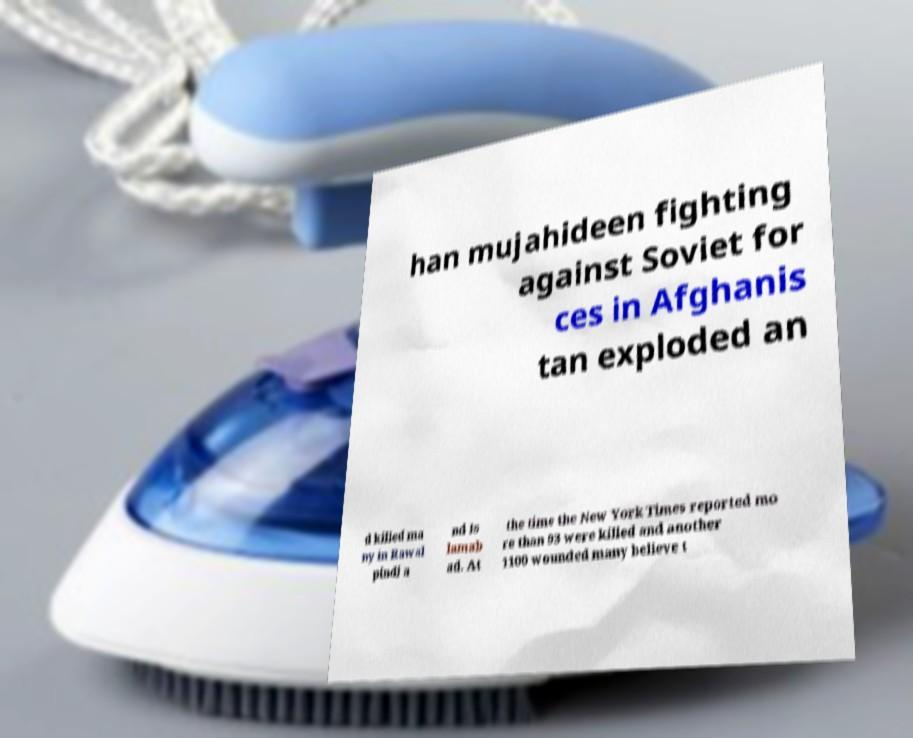There's text embedded in this image that I need extracted. Can you transcribe it verbatim? han mujahideen fighting against Soviet for ces in Afghanis tan exploded an d killed ma ny in Rawal pindi a nd Is lamab ad. At the time the New York Times reported mo re than 93 were killed and another 1100 wounded many believe t 